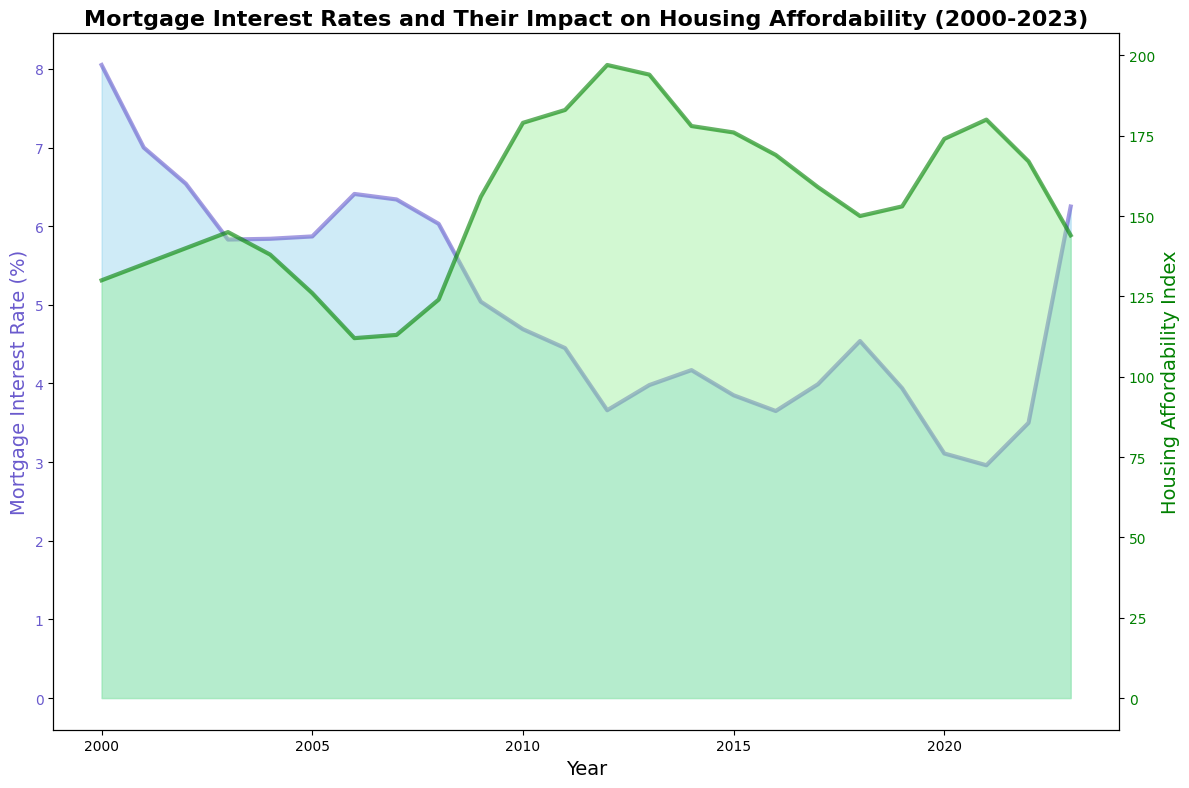What is the trend in mortgage interest rates from 2000 to 2023? To find the trend in mortgage interest rates from 2000 to 2023, visually follow the blue line or area on the left y-axis of the chart. Generally, the trend shows a decrease from 2000 to 2012, a slight increase until 2018, another decrease till 2021, and a sharp increase thereafter.
Answer: Decreasing, then increasing, then decreasing, and finally sharply increasing In which year did the mortgage interest rate reach its lowest point? Locate the blue line for mortgage interest rates and identify the lowest point. It occurs in the year 2021.
Answer: 2021 How does the Housing Affordability Index in 2012 compare to the index in 2000? Compare the green line for Housing Affordability Index in 2000 and 2012. In 2000, the index was 130, while in 2012, it was 197.
Answer: Higher in 2012 What is the average mortgage interest rate for the years 2020 to 2022? Average the mortgage interest rates for the years 2020, 2021, and 2022. (3.11 + 2.96 + 3.50) / 3 = 3.19
Answer: 3.19 Which year had the highest Housing Affordability Index, and what was its value? Scan the green line to find the peak of the Housing Affordability Index, which occurs in 2012 with a value of 197.
Answer: 2012, 197 Compare the Housing Affordability Index between the years 2006 and 2013. Identify the values of the Housing Affordability Index for 2006 (112) and 2013 (194). Compare them and note that 2013 is higher.
Answer: 2013 is higher What is the difference in Housing Affordability Index between 2010 and 2023? Subtract the value of the Housing Affordability Index in 2023 (144) from the value in 2010 (179). 179 - 144 = 35
Answer: 35 What color represents the Mortgage Interest Rate in the chart? The fill color for the Mortgage Interest Rate area chart is sky blue, while the line color is Slate blue.
Answer: Sky blue and Slate blue Which year observed the highest mortgage interest rate during the period 2008 to 2023? Observe the years from 2008 to 2023 on the blue line and note the highest point, which occurs in 2023 with a rate of 6.25%.
Answer: 2023 What correlation can be inferred between mortgage interest rates and housing affordability from 2000 to 2023? An inverse relationship is generally observed where increases in mortgage interest rates correspond to decreases in Housing Affordability Index, and vice versa. This trend highlights that as interest rates rise, housing becomes less affordable.
Answer: Inverse relationship 